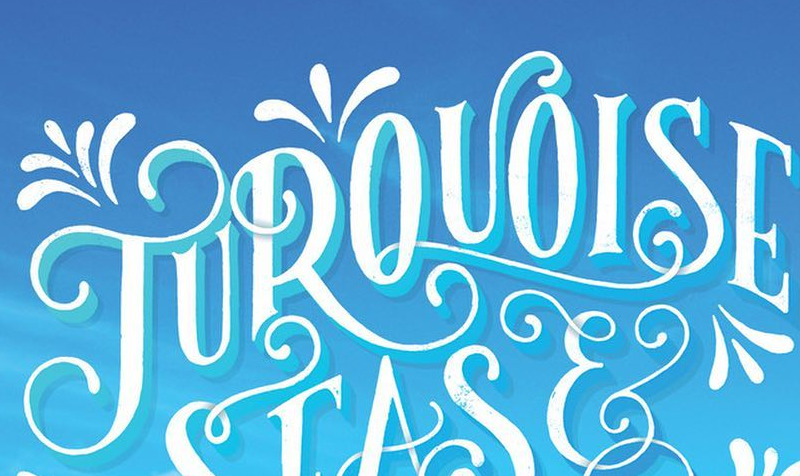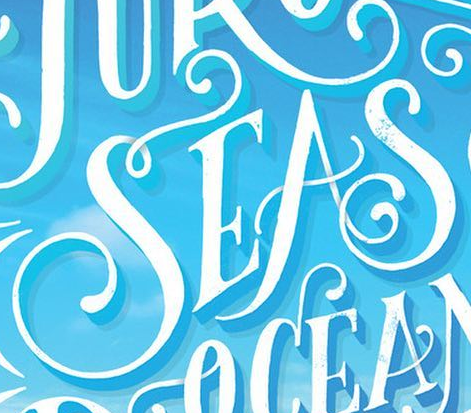What words are shown in these images in order, separated by a semicolon? TUROUOISE; SEAS 